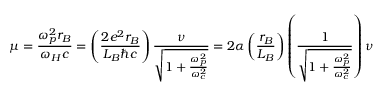<formula> <loc_0><loc_0><loc_500><loc_500>\mu = { \frac { \omega _ { p } ^ { 2 } r _ { B } } { \omega _ { H } c } } = \left ( { \frac { 2 e ^ { 2 } r _ { B } } { L _ { B } \hbar { c } } } \right ) { \frac { \nu } { \sqrt { 1 + { \frac { \omega _ { p } ^ { 2 } } { \omega _ { c } ^ { 2 } } } } } } = 2 \alpha \left ( { \frac { r _ { B } } { L _ { B } } } \right ) \left ( { \frac { 1 } { \sqrt { 1 + { \frac { \omega _ { p } ^ { 2 } } { \omega _ { c } ^ { 2 } } } } } } \right ) \nu</formula> 